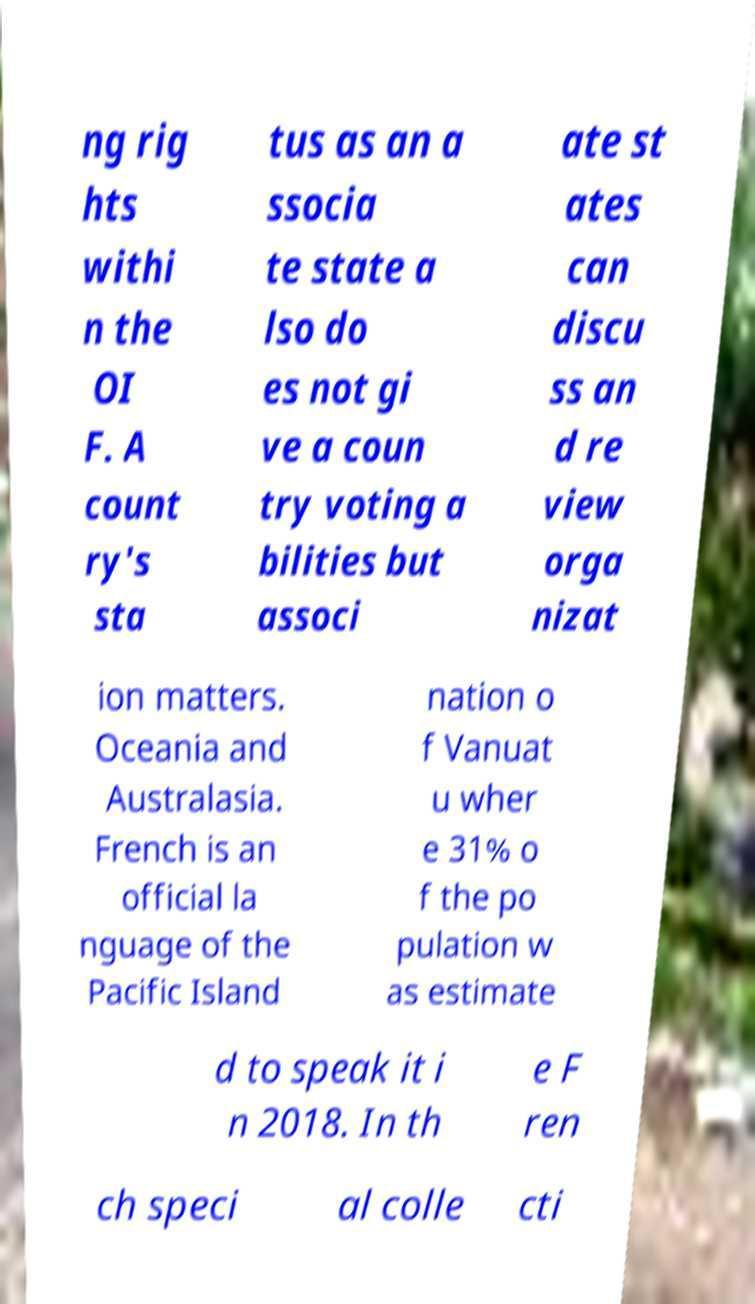Please read and relay the text visible in this image. What does it say? ng rig hts withi n the OI F. A count ry's sta tus as an a ssocia te state a lso do es not gi ve a coun try voting a bilities but associ ate st ates can discu ss an d re view orga nizat ion matters. Oceania and Australasia. French is an official la nguage of the Pacific Island nation o f Vanuat u wher e 31% o f the po pulation w as estimate d to speak it i n 2018. In th e F ren ch speci al colle cti 